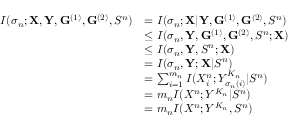Convert formula to latex. <formula><loc_0><loc_0><loc_500><loc_500>\begin{array} { r l } { I ( \sigma _ { n } ; X , Y , G ^ { ( 1 ) } , G ^ { ( 2 ) } , S ^ { n } ) } & { = I ( \sigma _ { n } ; X | Y , G ^ { ( 1 ) } , G ^ { ( 2 ) } , S ^ { n } ) } \\ & { \leq I ( \sigma _ { n } , Y , G ^ { ( 1 ) } , G ^ { ( 2 ) } , S ^ { n } ; X ) } \\ & { \leq I ( \sigma _ { n } , Y , S ^ { n } ; X ) } \\ & { = I ( \sigma _ { n } , Y ; X | S ^ { n } ) } \\ & { = \sum _ { i = 1 } ^ { m _ { n } } I ( X _ { i } ^ { n } ; Y _ { \sigma _ { n } ( i ) } ^ { K _ { n } } | S ^ { n } ) } \\ & { = m _ { n } I ( X ^ { n } ; Y ^ { K _ { n } } | S ^ { n } ) } \\ & { = m _ { n } I ( X ^ { n } ; Y ^ { K _ { n } } , S ^ { n } ) } \end{array}</formula> 